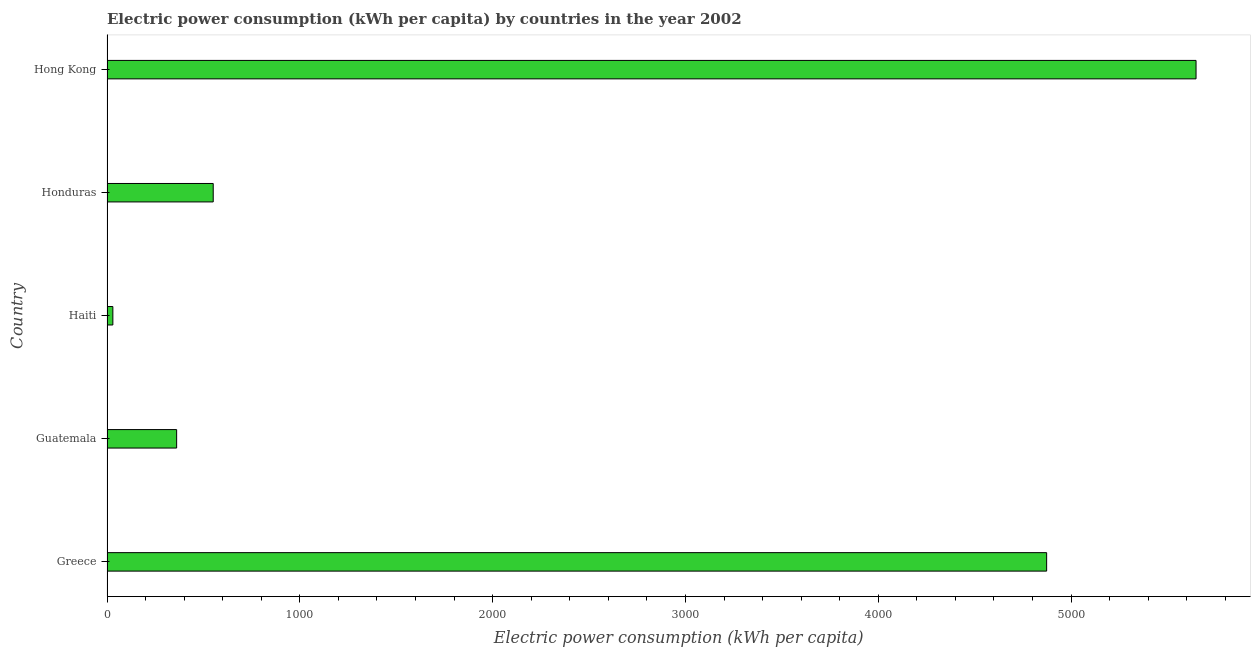Does the graph contain any zero values?
Ensure brevity in your answer.  No. Does the graph contain grids?
Provide a short and direct response. No. What is the title of the graph?
Your answer should be very brief. Electric power consumption (kWh per capita) by countries in the year 2002. What is the label or title of the X-axis?
Give a very brief answer. Electric power consumption (kWh per capita). What is the label or title of the Y-axis?
Provide a succinct answer. Country. What is the electric power consumption in Haiti?
Make the answer very short. 30.33. Across all countries, what is the maximum electric power consumption?
Give a very brief answer. 5647.9. Across all countries, what is the minimum electric power consumption?
Your answer should be compact. 30.33. In which country was the electric power consumption maximum?
Keep it short and to the point. Hong Kong. In which country was the electric power consumption minimum?
Provide a succinct answer. Haiti. What is the sum of the electric power consumption?
Your answer should be very brief. 1.15e+04. What is the difference between the electric power consumption in Greece and Haiti?
Give a very brief answer. 4842.78. What is the average electric power consumption per country?
Your response must be concise. 2292.67. What is the median electric power consumption?
Your response must be concise. 550.85. In how many countries, is the electric power consumption greater than 3000 kWh per capita?
Make the answer very short. 2. What is the ratio of the electric power consumption in Haiti to that in Hong Kong?
Make the answer very short. 0.01. Is the difference between the electric power consumption in Greece and Haiti greater than the difference between any two countries?
Give a very brief answer. No. What is the difference between the highest and the second highest electric power consumption?
Ensure brevity in your answer.  774.78. Is the sum of the electric power consumption in Greece and Honduras greater than the maximum electric power consumption across all countries?
Keep it short and to the point. No. What is the difference between the highest and the lowest electric power consumption?
Ensure brevity in your answer.  5617.56. In how many countries, is the electric power consumption greater than the average electric power consumption taken over all countries?
Your response must be concise. 2. How many countries are there in the graph?
Offer a terse response. 5. What is the Electric power consumption (kWh per capita) of Greece?
Provide a succinct answer. 4873.12. What is the Electric power consumption (kWh per capita) in Guatemala?
Offer a terse response. 361.14. What is the Electric power consumption (kWh per capita) in Haiti?
Offer a terse response. 30.33. What is the Electric power consumption (kWh per capita) of Honduras?
Your answer should be very brief. 550.85. What is the Electric power consumption (kWh per capita) of Hong Kong?
Keep it short and to the point. 5647.9. What is the difference between the Electric power consumption (kWh per capita) in Greece and Guatemala?
Provide a short and direct response. 4511.98. What is the difference between the Electric power consumption (kWh per capita) in Greece and Haiti?
Ensure brevity in your answer.  4842.79. What is the difference between the Electric power consumption (kWh per capita) in Greece and Honduras?
Provide a succinct answer. 4322.27. What is the difference between the Electric power consumption (kWh per capita) in Greece and Hong Kong?
Provide a short and direct response. -774.78. What is the difference between the Electric power consumption (kWh per capita) in Guatemala and Haiti?
Make the answer very short. 330.81. What is the difference between the Electric power consumption (kWh per capita) in Guatemala and Honduras?
Give a very brief answer. -189.71. What is the difference between the Electric power consumption (kWh per capita) in Guatemala and Hong Kong?
Your answer should be very brief. -5286.76. What is the difference between the Electric power consumption (kWh per capita) in Haiti and Honduras?
Provide a short and direct response. -520.52. What is the difference between the Electric power consumption (kWh per capita) in Haiti and Hong Kong?
Your response must be concise. -5617.56. What is the difference between the Electric power consumption (kWh per capita) in Honduras and Hong Kong?
Your answer should be compact. -5097.05. What is the ratio of the Electric power consumption (kWh per capita) in Greece to that in Guatemala?
Make the answer very short. 13.49. What is the ratio of the Electric power consumption (kWh per capita) in Greece to that in Haiti?
Offer a very short reply. 160.65. What is the ratio of the Electric power consumption (kWh per capita) in Greece to that in Honduras?
Offer a very short reply. 8.85. What is the ratio of the Electric power consumption (kWh per capita) in Greece to that in Hong Kong?
Your response must be concise. 0.86. What is the ratio of the Electric power consumption (kWh per capita) in Guatemala to that in Haiti?
Your answer should be very brief. 11.9. What is the ratio of the Electric power consumption (kWh per capita) in Guatemala to that in Honduras?
Your answer should be compact. 0.66. What is the ratio of the Electric power consumption (kWh per capita) in Guatemala to that in Hong Kong?
Keep it short and to the point. 0.06. What is the ratio of the Electric power consumption (kWh per capita) in Haiti to that in Honduras?
Your answer should be very brief. 0.06. What is the ratio of the Electric power consumption (kWh per capita) in Haiti to that in Hong Kong?
Keep it short and to the point. 0.01. What is the ratio of the Electric power consumption (kWh per capita) in Honduras to that in Hong Kong?
Your answer should be very brief. 0.1. 